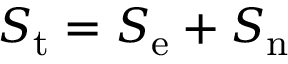Convert formula to latex. <formula><loc_0><loc_0><loc_500><loc_500>S _ { t } = S _ { e } + S _ { n }</formula> 